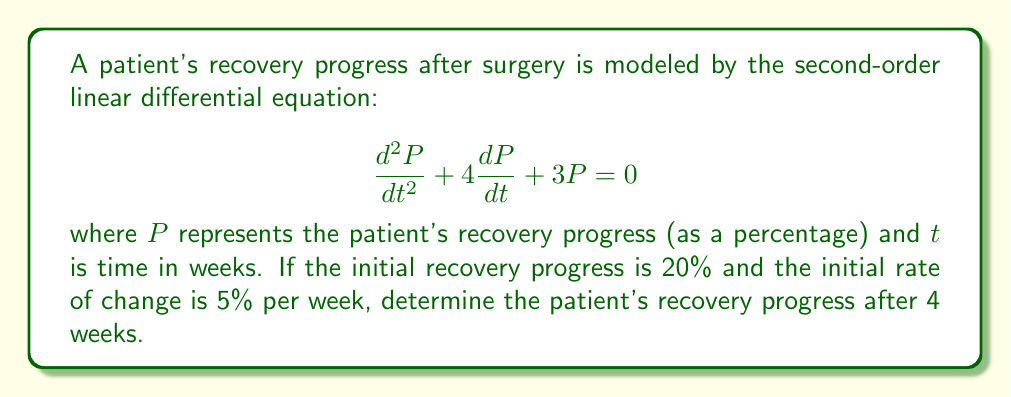Can you answer this question? To solve this problem, we follow these steps:

1) The general solution for this second-order linear differential equation is:

   $$P(t) = c_1e^{-t} + c_2e^{-3t}$$

2) We need to find $c_1$ and $c_2$ using the initial conditions:
   
   At $t=0$, $P(0) = 20$ and $P'(0) = 5$

3) Using the first condition:

   $$20 = c_1 + c_2$$

4) For the second condition, we differentiate $P(t)$:

   $$P'(t) = -c_1e^{-t} - 3c_2e^{-3t}$$

   At $t=0$:

   $$5 = -c_1 - 3c_2$$

5) Now we have a system of equations:

   $$c_1 + c_2 = 20$$
   $$c_1 + 3c_2 = -5$$

6) Subtracting the second equation from the first:

   $$-2c_2 = 25$$
   $$c_2 = -12.5$$

7) Substituting back:

   $$c_1 = 20 - (-12.5) = 32.5$$

8) Our solution is:

   $$P(t) = 32.5e^{-t} - 12.5e^{-3t}$$

9) To find the progress after 4 weeks, we calculate $P(4)$:

   $$P(4) = 32.5e^{-4} - 12.5e^{-12}$$

10) Using a calculator:

    $$P(4) \approx 32.5(0.0183) - 12.5(0.000006) \approx 0.5948 \approx 59.48\%$$
Answer: The patient's recovery progress after 4 weeks is approximately 59.48%. 